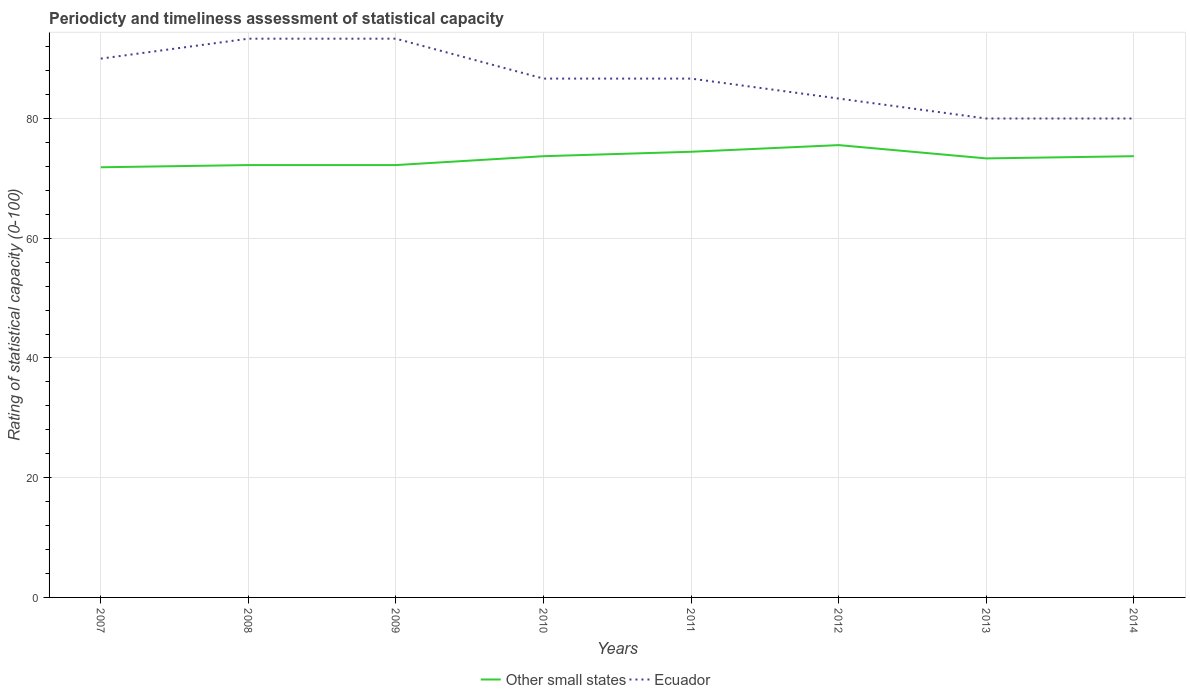Does the line corresponding to Other small states intersect with the line corresponding to Ecuador?
Your answer should be very brief. No. Across all years, what is the maximum rating of statistical capacity in Ecuador?
Offer a terse response. 80. What is the total rating of statistical capacity in Other small states in the graph?
Give a very brief answer. -0.74. What is the difference between the highest and the second highest rating of statistical capacity in Ecuador?
Keep it short and to the point. 13.33. What is the difference between the highest and the lowest rating of statistical capacity in Ecuador?
Give a very brief answer. 5. How many lines are there?
Provide a short and direct response. 2. How many years are there in the graph?
Keep it short and to the point. 8. Are the values on the major ticks of Y-axis written in scientific E-notation?
Ensure brevity in your answer.  No. How are the legend labels stacked?
Make the answer very short. Horizontal. What is the title of the graph?
Provide a succinct answer. Periodicty and timeliness assessment of statistical capacity. What is the label or title of the X-axis?
Ensure brevity in your answer.  Years. What is the label or title of the Y-axis?
Provide a short and direct response. Rating of statistical capacity (0-100). What is the Rating of statistical capacity (0-100) in Other small states in 2007?
Make the answer very short. 71.85. What is the Rating of statistical capacity (0-100) in Ecuador in 2007?
Provide a short and direct response. 90. What is the Rating of statistical capacity (0-100) of Other small states in 2008?
Make the answer very short. 72.22. What is the Rating of statistical capacity (0-100) of Ecuador in 2008?
Give a very brief answer. 93.33. What is the Rating of statistical capacity (0-100) of Other small states in 2009?
Keep it short and to the point. 72.22. What is the Rating of statistical capacity (0-100) in Ecuador in 2009?
Make the answer very short. 93.33. What is the Rating of statistical capacity (0-100) of Other small states in 2010?
Your answer should be very brief. 73.7. What is the Rating of statistical capacity (0-100) of Ecuador in 2010?
Offer a very short reply. 86.67. What is the Rating of statistical capacity (0-100) in Other small states in 2011?
Offer a very short reply. 74.44. What is the Rating of statistical capacity (0-100) of Ecuador in 2011?
Offer a very short reply. 86.67. What is the Rating of statistical capacity (0-100) in Other small states in 2012?
Your answer should be very brief. 75.56. What is the Rating of statistical capacity (0-100) of Ecuador in 2012?
Make the answer very short. 83.33. What is the Rating of statistical capacity (0-100) of Other small states in 2013?
Make the answer very short. 73.33. What is the Rating of statistical capacity (0-100) in Ecuador in 2013?
Ensure brevity in your answer.  80. What is the Rating of statistical capacity (0-100) in Other small states in 2014?
Provide a short and direct response. 73.7. Across all years, what is the maximum Rating of statistical capacity (0-100) in Other small states?
Offer a terse response. 75.56. Across all years, what is the maximum Rating of statistical capacity (0-100) in Ecuador?
Offer a very short reply. 93.33. Across all years, what is the minimum Rating of statistical capacity (0-100) in Other small states?
Make the answer very short. 71.85. What is the total Rating of statistical capacity (0-100) in Other small states in the graph?
Keep it short and to the point. 587.04. What is the total Rating of statistical capacity (0-100) in Ecuador in the graph?
Your answer should be very brief. 693.33. What is the difference between the Rating of statistical capacity (0-100) of Other small states in 2007 and that in 2008?
Provide a succinct answer. -0.37. What is the difference between the Rating of statistical capacity (0-100) in Other small states in 2007 and that in 2009?
Keep it short and to the point. -0.37. What is the difference between the Rating of statistical capacity (0-100) of Other small states in 2007 and that in 2010?
Keep it short and to the point. -1.85. What is the difference between the Rating of statistical capacity (0-100) of Other small states in 2007 and that in 2011?
Provide a succinct answer. -2.59. What is the difference between the Rating of statistical capacity (0-100) of Ecuador in 2007 and that in 2011?
Make the answer very short. 3.33. What is the difference between the Rating of statistical capacity (0-100) in Other small states in 2007 and that in 2012?
Ensure brevity in your answer.  -3.7. What is the difference between the Rating of statistical capacity (0-100) of Ecuador in 2007 and that in 2012?
Provide a short and direct response. 6.67. What is the difference between the Rating of statistical capacity (0-100) of Other small states in 2007 and that in 2013?
Offer a very short reply. -1.48. What is the difference between the Rating of statistical capacity (0-100) in Other small states in 2007 and that in 2014?
Make the answer very short. -1.85. What is the difference between the Rating of statistical capacity (0-100) in Ecuador in 2008 and that in 2009?
Offer a very short reply. 0. What is the difference between the Rating of statistical capacity (0-100) of Other small states in 2008 and that in 2010?
Your response must be concise. -1.48. What is the difference between the Rating of statistical capacity (0-100) in Other small states in 2008 and that in 2011?
Provide a short and direct response. -2.22. What is the difference between the Rating of statistical capacity (0-100) in Ecuador in 2008 and that in 2011?
Keep it short and to the point. 6.67. What is the difference between the Rating of statistical capacity (0-100) of Other small states in 2008 and that in 2012?
Keep it short and to the point. -3.33. What is the difference between the Rating of statistical capacity (0-100) of Ecuador in 2008 and that in 2012?
Provide a short and direct response. 10. What is the difference between the Rating of statistical capacity (0-100) of Other small states in 2008 and that in 2013?
Give a very brief answer. -1.11. What is the difference between the Rating of statistical capacity (0-100) of Ecuador in 2008 and that in 2013?
Your response must be concise. 13.33. What is the difference between the Rating of statistical capacity (0-100) of Other small states in 2008 and that in 2014?
Your answer should be compact. -1.48. What is the difference between the Rating of statistical capacity (0-100) of Ecuador in 2008 and that in 2014?
Ensure brevity in your answer.  13.33. What is the difference between the Rating of statistical capacity (0-100) in Other small states in 2009 and that in 2010?
Your answer should be compact. -1.48. What is the difference between the Rating of statistical capacity (0-100) in Ecuador in 2009 and that in 2010?
Provide a succinct answer. 6.67. What is the difference between the Rating of statistical capacity (0-100) of Other small states in 2009 and that in 2011?
Your answer should be very brief. -2.22. What is the difference between the Rating of statistical capacity (0-100) in Other small states in 2009 and that in 2012?
Provide a short and direct response. -3.33. What is the difference between the Rating of statistical capacity (0-100) in Other small states in 2009 and that in 2013?
Ensure brevity in your answer.  -1.11. What is the difference between the Rating of statistical capacity (0-100) in Ecuador in 2009 and that in 2013?
Keep it short and to the point. 13.33. What is the difference between the Rating of statistical capacity (0-100) in Other small states in 2009 and that in 2014?
Make the answer very short. -1.48. What is the difference between the Rating of statistical capacity (0-100) in Ecuador in 2009 and that in 2014?
Provide a short and direct response. 13.33. What is the difference between the Rating of statistical capacity (0-100) in Other small states in 2010 and that in 2011?
Offer a terse response. -0.74. What is the difference between the Rating of statistical capacity (0-100) in Ecuador in 2010 and that in 2011?
Provide a succinct answer. 0. What is the difference between the Rating of statistical capacity (0-100) of Other small states in 2010 and that in 2012?
Offer a very short reply. -1.85. What is the difference between the Rating of statistical capacity (0-100) in Other small states in 2010 and that in 2013?
Your answer should be very brief. 0.37. What is the difference between the Rating of statistical capacity (0-100) in Ecuador in 2010 and that in 2013?
Make the answer very short. 6.67. What is the difference between the Rating of statistical capacity (0-100) in Other small states in 2010 and that in 2014?
Give a very brief answer. 0. What is the difference between the Rating of statistical capacity (0-100) of Ecuador in 2010 and that in 2014?
Keep it short and to the point. 6.67. What is the difference between the Rating of statistical capacity (0-100) in Other small states in 2011 and that in 2012?
Your answer should be compact. -1.11. What is the difference between the Rating of statistical capacity (0-100) in Ecuador in 2011 and that in 2012?
Give a very brief answer. 3.33. What is the difference between the Rating of statistical capacity (0-100) of Other small states in 2011 and that in 2014?
Keep it short and to the point. 0.74. What is the difference between the Rating of statistical capacity (0-100) in Ecuador in 2011 and that in 2014?
Your answer should be very brief. 6.67. What is the difference between the Rating of statistical capacity (0-100) of Other small states in 2012 and that in 2013?
Ensure brevity in your answer.  2.22. What is the difference between the Rating of statistical capacity (0-100) of Other small states in 2012 and that in 2014?
Your answer should be very brief. 1.85. What is the difference between the Rating of statistical capacity (0-100) of Other small states in 2013 and that in 2014?
Your response must be concise. -0.37. What is the difference between the Rating of statistical capacity (0-100) of Ecuador in 2013 and that in 2014?
Offer a very short reply. 0. What is the difference between the Rating of statistical capacity (0-100) in Other small states in 2007 and the Rating of statistical capacity (0-100) in Ecuador in 2008?
Your answer should be very brief. -21.48. What is the difference between the Rating of statistical capacity (0-100) of Other small states in 2007 and the Rating of statistical capacity (0-100) of Ecuador in 2009?
Your answer should be compact. -21.48. What is the difference between the Rating of statistical capacity (0-100) of Other small states in 2007 and the Rating of statistical capacity (0-100) of Ecuador in 2010?
Make the answer very short. -14.81. What is the difference between the Rating of statistical capacity (0-100) in Other small states in 2007 and the Rating of statistical capacity (0-100) in Ecuador in 2011?
Your answer should be very brief. -14.81. What is the difference between the Rating of statistical capacity (0-100) in Other small states in 2007 and the Rating of statistical capacity (0-100) in Ecuador in 2012?
Provide a succinct answer. -11.48. What is the difference between the Rating of statistical capacity (0-100) in Other small states in 2007 and the Rating of statistical capacity (0-100) in Ecuador in 2013?
Give a very brief answer. -8.15. What is the difference between the Rating of statistical capacity (0-100) of Other small states in 2007 and the Rating of statistical capacity (0-100) of Ecuador in 2014?
Give a very brief answer. -8.15. What is the difference between the Rating of statistical capacity (0-100) of Other small states in 2008 and the Rating of statistical capacity (0-100) of Ecuador in 2009?
Offer a terse response. -21.11. What is the difference between the Rating of statistical capacity (0-100) in Other small states in 2008 and the Rating of statistical capacity (0-100) in Ecuador in 2010?
Make the answer very short. -14.44. What is the difference between the Rating of statistical capacity (0-100) in Other small states in 2008 and the Rating of statistical capacity (0-100) in Ecuador in 2011?
Your response must be concise. -14.44. What is the difference between the Rating of statistical capacity (0-100) of Other small states in 2008 and the Rating of statistical capacity (0-100) of Ecuador in 2012?
Ensure brevity in your answer.  -11.11. What is the difference between the Rating of statistical capacity (0-100) in Other small states in 2008 and the Rating of statistical capacity (0-100) in Ecuador in 2013?
Provide a short and direct response. -7.78. What is the difference between the Rating of statistical capacity (0-100) in Other small states in 2008 and the Rating of statistical capacity (0-100) in Ecuador in 2014?
Your answer should be compact. -7.78. What is the difference between the Rating of statistical capacity (0-100) in Other small states in 2009 and the Rating of statistical capacity (0-100) in Ecuador in 2010?
Offer a very short reply. -14.44. What is the difference between the Rating of statistical capacity (0-100) in Other small states in 2009 and the Rating of statistical capacity (0-100) in Ecuador in 2011?
Your answer should be compact. -14.44. What is the difference between the Rating of statistical capacity (0-100) in Other small states in 2009 and the Rating of statistical capacity (0-100) in Ecuador in 2012?
Make the answer very short. -11.11. What is the difference between the Rating of statistical capacity (0-100) in Other small states in 2009 and the Rating of statistical capacity (0-100) in Ecuador in 2013?
Ensure brevity in your answer.  -7.78. What is the difference between the Rating of statistical capacity (0-100) in Other small states in 2009 and the Rating of statistical capacity (0-100) in Ecuador in 2014?
Give a very brief answer. -7.78. What is the difference between the Rating of statistical capacity (0-100) in Other small states in 2010 and the Rating of statistical capacity (0-100) in Ecuador in 2011?
Provide a short and direct response. -12.96. What is the difference between the Rating of statistical capacity (0-100) of Other small states in 2010 and the Rating of statistical capacity (0-100) of Ecuador in 2012?
Your response must be concise. -9.63. What is the difference between the Rating of statistical capacity (0-100) in Other small states in 2010 and the Rating of statistical capacity (0-100) in Ecuador in 2013?
Provide a succinct answer. -6.3. What is the difference between the Rating of statistical capacity (0-100) in Other small states in 2010 and the Rating of statistical capacity (0-100) in Ecuador in 2014?
Offer a terse response. -6.3. What is the difference between the Rating of statistical capacity (0-100) of Other small states in 2011 and the Rating of statistical capacity (0-100) of Ecuador in 2012?
Your answer should be compact. -8.89. What is the difference between the Rating of statistical capacity (0-100) of Other small states in 2011 and the Rating of statistical capacity (0-100) of Ecuador in 2013?
Offer a very short reply. -5.56. What is the difference between the Rating of statistical capacity (0-100) in Other small states in 2011 and the Rating of statistical capacity (0-100) in Ecuador in 2014?
Provide a short and direct response. -5.56. What is the difference between the Rating of statistical capacity (0-100) in Other small states in 2012 and the Rating of statistical capacity (0-100) in Ecuador in 2013?
Provide a succinct answer. -4.44. What is the difference between the Rating of statistical capacity (0-100) of Other small states in 2012 and the Rating of statistical capacity (0-100) of Ecuador in 2014?
Offer a very short reply. -4.44. What is the difference between the Rating of statistical capacity (0-100) in Other small states in 2013 and the Rating of statistical capacity (0-100) in Ecuador in 2014?
Your answer should be very brief. -6.67. What is the average Rating of statistical capacity (0-100) of Other small states per year?
Provide a short and direct response. 73.38. What is the average Rating of statistical capacity (0-100) of Ecuador per year?
Offer a terse response. 86.67. In the year 2007, what is the difference between the Rating of statistical capacity (0-100) in Other small states and Rating of statistical capacity (0-100) in Ecuador?
Give a very brief answer. -18.15. In the year 2008, what is the difference between the Rating of statistical capacity (0-100) of Other small states and Rating of statistical capacity (0-100) of Ecuador?
Offer a terse response. -21.11. In the year 2009, what is the difference between the Rating of statistical capacity (0-100) of Other small states and Rating of statistical capacity (0-100) of Ecuador?
Provide a short and direct response. -21.11. In the year 2010, what is the difference between the Rating of statistical capacity (0-100) of Other small states and Rating of statistical capacity (0-100) of Ecuador?
Ensure brevity in your answer.  -12.96. In the year 2011, what is the difference between the Rating of statistical capacity (0-100) of Other small states and Rating of statistical capacity (0-100) of Ecuador?
Offer a very short reply. -12.22. In the year 2012, what is the difference between the Rating of statistical capacity (0-100) in Other small states and Rating of statistical capacity (0-100) in Ecuador?
Give a very brief answer. -7.78. In the year 2013, what is the difference between the Rating of statistical capacity (0-100) in Other small states and Rating of statistical capacity (0-100) in Ecuador?
Ensure brevity in your answer.  -6.67. In the year 2014, what is the difference between the Rating of statistical capacity (0-100) in Other small states and Rating of statistical capacity (0-100) in Ecuador?
Your answer should be very brief. -6.3. What is the ratio of the Rating of statistical capacity (0-100) of Other small states in 2007 to that in 2010?
Provide a succinct answer. 0.97. What is the ratio of the Rating of statistical capacity (0-100) in Ecuador in 2007 to that in 2010?
Your answer should be compact. 1.04. What is the ratio of the Rating of statistical capacity (0-100) in Other small states in 2007 to that in 2011?
Provide a succinct answer. 0.97. What is the ratio of the Rating of statistical capacity (0-100) in Other small states in 2007 to that in 2012?
Make the answer very short. 0.95. What is the ratio of the Rating of statistical capacity (0-100) in Ecuador in 2007 to that in 2012?
Offer a terse response. 1.08. What is the ratio of the Rating of statistical capacity (0-100) of Other small states in 2007 to that in 2013?
Your answer should be compact. 0.98. What is the ratio of the Rating of statistical capacity (0-100) in Ecuador in 2007 to that in 2013?
Your response must be concise. 1.12. What is the ratio of the Rating of statistical capacity (0-100) in Other small states in 2007 to that in 2014?
Your answer should be very brief. 0.97. What is the ratio of the Rating of statistical capacity (0-100) of Ecuador in 2007 to that in 2014?
Your response must be concise. 1.12. What is the ratio of the Rating of statistical capacity (0-100) in Other small states in 2008 to that in 2009?
Provide a short and direct response. 1. What is the ratio of the Rating of statistical capacity (0-100) of Ecuador in 2008 to that in 2009?
Offer a terse response. 1. What is the ratio of the Rating of statistical capacity (0-100) of Other small states in 2008 to that in 2010?
Your answer should be very brief. 0.98. What is the ratio of the Rating of statistical capacity (0-100) of Other small states in 2008 to that in 2011?
Your answer should be compact. 0.97. What is the ratio of the Rating of statistical capacity (0-100) in Other small states in 2008 to that in 2012?
Your answer should be compact. 0.96. What is the ratio of the Rating of statistical capacity (0-100) of Ecuador in 2008 to that in 2012?
Your response must be concise. 1.12. What is the ratio of the Rating of statistical capacity (0-100) of Other small states in 2008 to that in 2013?
Your response must be concise. 0.98. What is the ratio of the Rating of statistical capacity (0-100) of Other small states in 2008 to that in 2014?
Provide a succinct answer. 0.98. What is the ratio of the Rating of statistical capacity (0-100) of Ecuador in 2008 to that in 2014?
Offer a very short reply. 1.17. What is the ratio of the Rating of statistical capacity (0-100) of Other small states in 2009 to that in 2010?
Your answer should be very brief. 0.98. What is the ratio of the Rating of statistical capacity (0-100) of Ecuador in 2009 to that in 2010?
Keep it short and to the point. 1.08. What is the ratio of the Rating of statistical capacity (0-100) of Other small states in 2009 to that in 2011?
Give a very brief answer. 0.97. What is the ratio of the Rating of statistical capacity (0-100) of Ecuador in 2009 to that in 2011?
Ensure brevity in your answer.  1.08. What is the ratio of the Rating of statistical capacity (0-100) in Other small states in 2009 to that in 2012?
Provide a short and direct response. 0.96. What is the ratio of the Rating of statistical capacity (0-100) of Ecuador in 2009 to that in 2012?
Keep it short and to the point. 1.12. What is the ratio of the Rating of statistical capacity (0-100) of Other small states in 2009 to that in 2013?
Provide a short and direct response. 0.98. What is the ratio of the Rating of statistical capacity (0-100) in Other small states in 2009 to that in 2014?
Offer a terse response. 0.98. What is the ratio of the Rating of statistical capacity (0-100) of Ecuador in 2009 to that in 2014?
Give a very brief answer. 1.17. What is the ratio of the Rating of statistical capacity (0-100) in Other small states in 2010 to that in 2011?
Keep it short and to the point. 0.99. What is the ratio of the Rating of statistical capacity (0-100) in Other small states in 2010 to that in 2012?
Your answer should be very brief. 0.98. What is the ratio of the Rating of statistical capacity (0-100) in Other small states in 2010 to that in 2013?
Provide a succinct answer. 1.01. What is the ratio of the Rating of statistical capacity (0-100) of Other small states in 2010 to that in 2014?
Ensure brevity in your answer.  1. What is the ratio of the Rating of statistical capacity (0-100) of Other small states in 2011 to that in 2013?
Give a very brief answer. 1.02. What is the ratio of the Rating of statistical capacity (0-100) of Ecuador in 2011 to that in 2014?
Make the answer very short. 1.08. What is the ratio of the Rating of statistical capacity (0-100) in Other small states in 2012 to that in 2013?
Offer a very short reply. 1.03. What is the ratio of the Rating of statistical capacity (0-100) of Ecuador in 2012 to that in 2013?
Give a very brief answer. 1.04. What is the ratio of the Rating of statistical capacity (0-100) of Other small states in 2012 to that in 2014?
Give a very brief answer. 1.03. What is the ratio of the Rating of statistical capacity (0-100) in Ecuador in 2012 to that in 2014?
Your response must be concise. 1.04. What is the ratio of the Rating of statistical capacity (0-100) in Ecuador in 2013 to that in 2014?
Your response must be concise. 1. What is the difference between the highest and the second highest Rating of statistical capacity (0-100) of Ecuador?
Provide a succinct answer. 0. What is the difference between the highest and the lowest Rating of statistical capacity (0-100) of Other small states?
Your response must be concise. 3.7. What is the difference between the highest and the lowest Rating of statistical capacity (0-100) in Ecuador?
Offer a very short reply. 13.33. 